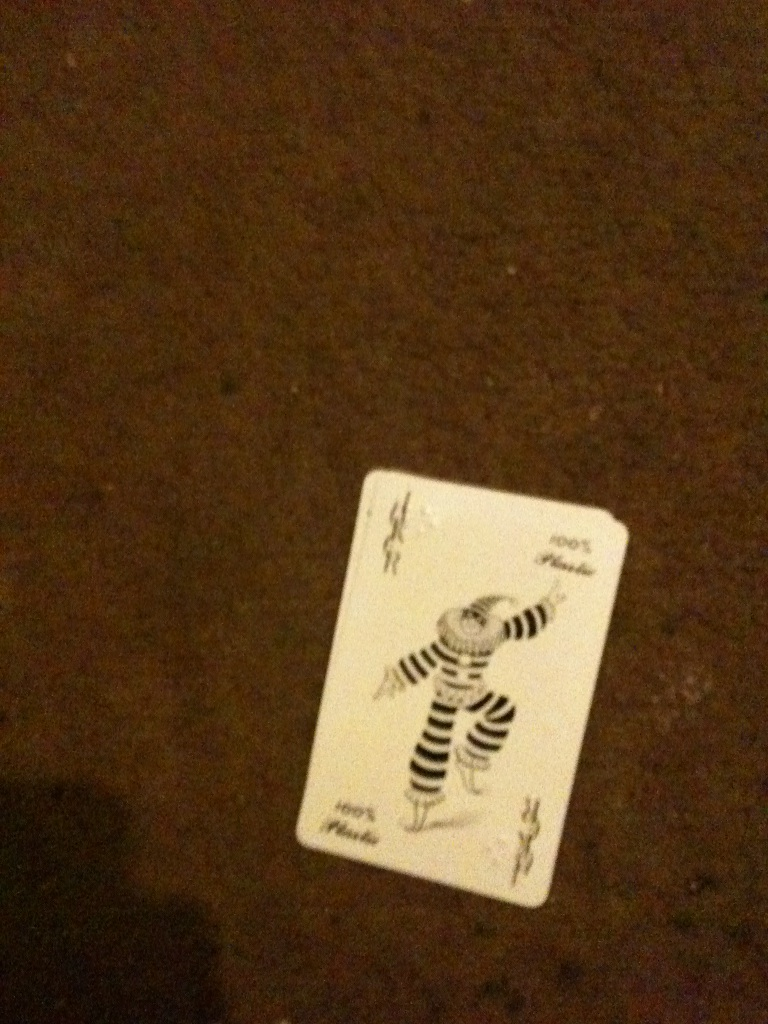What kind of games can include a Joker card like this? The Joker card is quite versatile and can be used in a variety of card games. For instance, in the game of Poker, a Joker can often act as a wild card or as a 'bug' which counts as a fifth ace or to complete a straight or flush. In games like Rummy, the Joker can be used as a replacement for any card to form sets and sequences. Additionally, it plays a unique role in certain solitaire games and children's games, like Crazy Eights or Old Maid. 